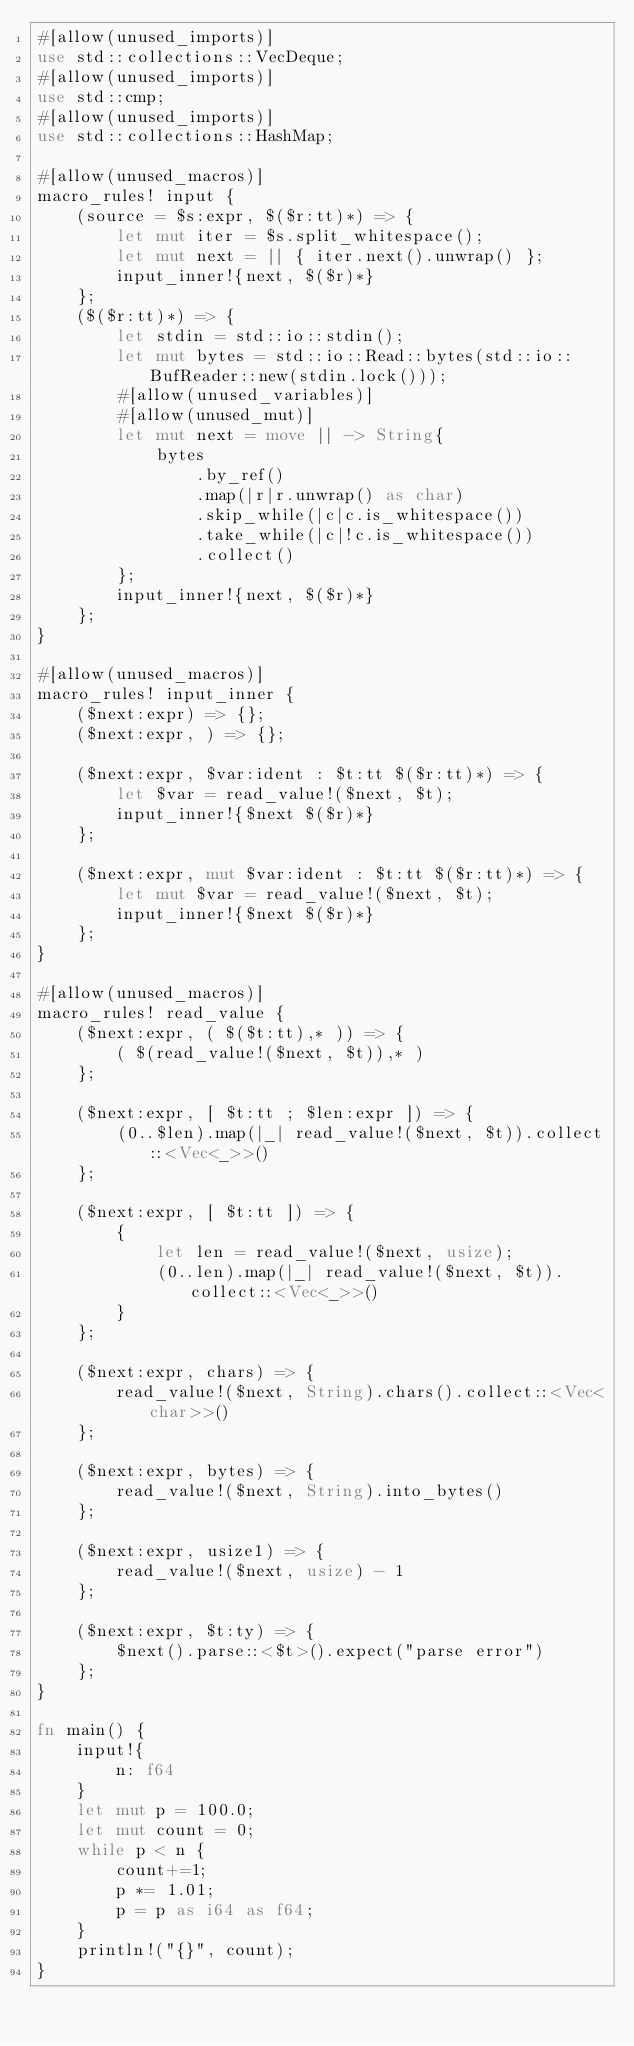Convert code to text. <code><loc_0><loc_0><loc_500><loc_500><_Rust_>#[allow(unused_imports)]
use std::collections::VecDeque;
#[allow(unused_imports)]
use std::cmp;
#[allow(unused_imports)]
use std::collections::HashMap;

#[allow(unused_macros)]
macro_rules! input {
    (source = $s:expr, $($r:tt)*) => {
        let mut iter = $s.split_whitespace();
        let mut next = || { iter.next().unwrap() };
        input_inner!{next, $($r)*}
    };
    ($($r:tt)*) => {
        let stdin = std::io::stdin();
        let mut bytes = std::io::Read::bytes(std::io::BufReader::new(stdin.lock()));
        #[allow(unused_variables)]
        #[allow(unused_mut)]
        let mut next = move || -> String{
            bytes
                .by_ref()
                .map(|r|r.unwrap() as char)
                .skip_while(|c|c.is_whitespace())
                .take_while(|c|!c.is_whitespace())
                .collect()
        };
        input_inner!{next, $($r)*}
    };
}

#[allow(unused_macros)]
macro_rules! input_inner {
    ($next:expr) => {};
    ($next:expr, ) => {};

    ($next:expr, $var:ident : $t:tt $($r:tt)*) => {
        let $var = read_value!($next, $t);
        input_inner!{$next $($r)*}
    };
 
    ($next:expr, mut $var:ident : $t:tt $($r:tt)*) => {
        let mut $var = read_value!($next, $t);
        input_inner!{$next $($r)*}
    };
}

#[allow(unused_macros)]
macro_rules! read_value {
    ($next:expr, ( $($t:tt),* )) => {
        ( $(read_value!($next, $t)),* )
    };

    ($next:expr, [ $t:tt ; $len:expr ]) => {
        (0..$len).map(|_| read_value!($next, $t)).collect::<Vec<_>>()
    };
 
    ($next:expr, [ $t:tt ]) => {
        {
            let len = read_value!($next, usize);
            (0..len).map(|_| read_value!($next, $t)).collect::<Vec<_>>()
        }
    };
 
    ($next:expr, chars) => {
        read_value!($next, String).chars().collect::<Vec<char>>()
    };
 
    ($next:expr, bytes) => {
        read_value!($next, String).into_bytes()
    };
 
    ($next:expr, usize1) => {
        read_value!($next, usize) - 1
    };
 
    ($next:expr, $t:ty) => {
        $next().parse::<$t>().expect("parse error")
    };
}

fn main() {
    input!{
        n: f64
    }
    let mut p = 100.0;
    let mut count = 0;
    while p < n {
        count+=1;
        p *= 1.01;
        p = p as i64 as f64;
    }
    println!("{}", count);
}
</code> 